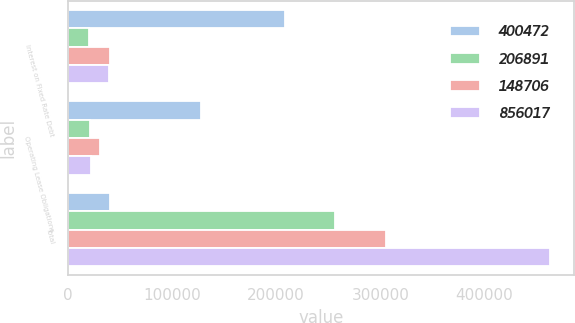<chart> <loc_0><loc_0><loc_500><loc_500><stacked_bar_chart><ecel><fcel>Interest on Fixed Rate Debt<fcel>Operating Lease Obligations<fcel>Total<nl><fcel>400472<fcel>208773<fcel>127387<fcel>40495<nl><fcel>206891<fcel>20247<fcel>21300<fcel>256339<nl><fcel>148706<fcel>40495<fcel>31174<fcel>305149<nl><fcel>856017<fcel>39837<fcel>22648<fcel>462957<nl></chart> 